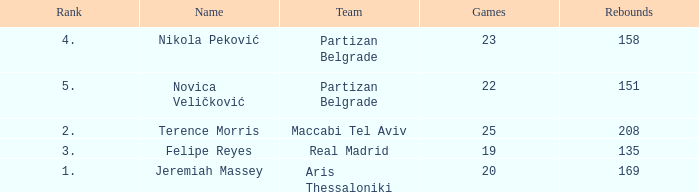What is the number of Games for Partizan Belgrade player Nikola Peković with a Rank of more than 4? None. Help me parse the entirety of this table. {'header': ['Rank', 'Name', 'Team', 'Games', 'Rebounds'], 'rows': [['4.', 'Nikola Peković', 'Partizan Belgrade', '23', '158'], ['5.', 'Novica Veličković', 'Partizan Belgrade', '22', '151'], ['2.', 'Terence Morris', 'Maccabi Tel Aviv', '25', '208'], ['3.', 'Felipe Reyes', 'Real Madrid', '19', '135'], ['1.', 'Jeremiah Massey', 'Aris Thessaloniki', '20', '169']]} 